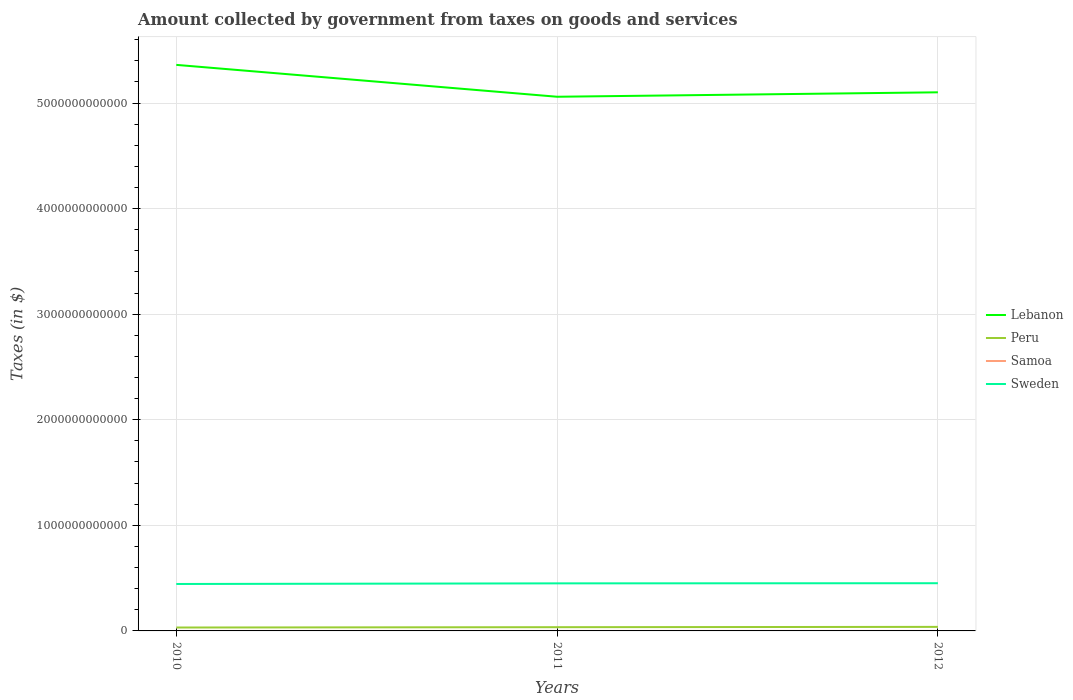Is the number of lines equal to the number of legend labels?
Your answer should be very brief. Yes. Across all years, what is the maximum amount collected by government from taxes on goods and services in Sweden?
Your answer should be very brief. 4.45e+11. In which year was the amount collected by government from taxes on goods and services in Lebanon maximum?
Your answer should be compact. 2011. What is the total amount collected by government from taxes on goods and services in Lebanon in the graph?
Offer a terse response. -4.20e+1. What is the difference between the highest and the second highest amount collected by government from taxes on goods and services in Peru?
Offer a terse response. 6.12e+09. What is the difference between the highest and the lowest amount collected by government from taxes on goods and services in Sweden?
Offer a very short reply. 2. How many years are there in the graph?
Offer a very short reply. 3. What is the difference between two consecutive major ticks on the Y-axis?
Give a very brief answer. 1.00e+12. Are the values on the major ticks of Y-axis written in scientific E-notation?
Provide a succinct answer. No. Does the graph contain any zero values?
Your answer should be compact. No. Does the graph contain grids?
Your answer should be very brief. Yes. Where does the legend appear in the graph?
Offer a terse response. Center right. How many legend labels are there?
Ensure brevity in your answer.  4. How are the legend labels stacked?
Provide a succinct answer. Vertical. What is the title of the graph?
Keep it short and to the point. Amount collected by government from taxes on goods and services. Does "Low income" appear as one of the legend labels in the graph?
Give a very brief answer. No. What is the label or title of the X-axis?
Provide a short and direct response. Years. What is the label or title of the Y-axis?
Give a very brief answer. Taxes (in $). What is the Taxes (in $) in Lebanon in 2010?
Make the answer very short. 5.36e+12. What is the Taxes (in $) in Peru in 2010?
Ensure brevity in your answer.  3.23e+1. What is the Taxes (in $) in Samoa in 2010?
Ensure brevity in your answer.  2.36e+05. What is the Taxes (in $) of Sweden in 2010?
Provide a succinct answer. 4.45e+11. What is the Taxes (in $) of Lebanon in 2011?
Make the answer very short. 5.06e+12. What is the Taxes (in $) in Peru in 2011?
Keep it short and to the point. 3.54e+1. What is the Taxes (in $) in Samoa in 2011?
Your answer should be very brief. 2.38e+05. What is the Taxes (in $) of Sweden in 2011?
Make the answer very short. 4.51e+11. What is the Taxes (in $) in Lebanon in 2012?
Offer a very short reply. 5.10e+12. What is the Taxes (in $) in Peru in 2012?
Provide a short and direct response. 3.84e+1. What is the Taxes (in $) in Samoa in 2012?
Keep it short and to the point. 2.32e+05. What is the Taxes (in $) of Sweden in 2012?
Your answer should be very brief. 4.52e+11. Across all years, what is the maximum Taxes (in $) of Lebanon?
Offer a terse response. 5.36e+12. Across all years, what is the maximum Taxes (in $) of Peru?
Offer a terse response. 3.84e+1. Across all years, what is the maximum Taxes (in $) of Samoa?
Keep it short and to the point. 2.38e+05. Across all years, what is the maximum Taxes (in $) in Sweden?
Your answer should be very brief. 4.52e+11. Across all years, what is the minimum Taxes (in $) in Lebanon?
Keep it short and to the point. 5.06e+12. Across all years, what is the minimum Taxes (in $) of Peru?
Offer a very short reply. 3.23e+1. Across all years, what is the minimum Taxes (in $) of Samoa?
Provide a succinct answer. 2.32e+05. Across all years, what is the minimum Taxes (in $) of Sweden?
Your response must be concise. 4.45e+11. What is the total Taxes (in $) of Lebanon in the graph?
Offer a very short reply. 1.55e+13. What is the total Taxes (in $) of Peru in the graph?
Provide a succinct answer. 1.06e+11. What is the total Taxes (in $) in Samoa in the graph?
Ensure brevity in your answer.  7.06e+05. What is the total Taxes (in $) in Sweden in the graph?
Your answer should be very brief. 1.35e+12. What is the difference between the Taxes (in $) of Lebanon in 2010 and that in 2011?
Your answer should be very brief. 3.02e+11. What is the difference between the Taxes (in $) of Peru in 2010 and that in 2011?
Provide a short and direct response. -3.18e+09. What is the difference between the Taxes (in $) in Samoa in 2010 and that in 2011?
Make the answer very short. -1013.36. What is the difference between the Taxes (in $) of Sweden in 2010 and that in 2011?
Keep it short and to the point. -6.03e+09. What is the difference between the Taxes (in $) in Lebanon in 2010 and that in 2012?
Provide a succinct answer. 2.60e+11. What is the difference between the Taxes (in $) in Peru in 2010 and that in 2012?
Keep it short and to the point. -6.12e+09. What is the difference between the Taxes (in $) in Samoa in 2010 and that in 2012?
Provide a succinct answer. 4110.08. What is the difference between the Taxes (in $) in Sweden in 2010 and that in 2012?
Offer a very short reply. -7.29e+09. What is the difference between the Taxes (in $) in Lebanon in 2011 and that in 2012?
Ensure brevity in your answer.  -4.20e+1. What is the difference between the Taxes (in $) in Peru in 2011 and that in 2012?
Make the answer very short. -2.94e+09. What is the difference between the Taxes (in $) in Samoa in 2011 and that in 2012?
Provide a succinct answer. 5123.44. What is the difference between the Taxes (in $) of Sweden in 2011 and that in 2012?
Your response must be concise. -1.26e+09. What is the difference between the Taxes (in $) of Lebanon in 2010 and the Taxes (in $) of Peru in 2011?
Provide a succinct answer. 5.33e+12. What is the difference between the Taxes (in $) in Lebanon in 2010 and the Taxes (in $) in Samoa in 2011?
Provide a succinct answer. 5.36e+12. What is the difference between the Taxes (in $) of Lebanon in 2010 and the Taxes (in $) of Sweden in 2011?
Offer a very short reply. 4.91e+12. What is the difference between the Taxes (in $) of Peru in 2010 and the Taxes (in $) of Samoa in 2011?
Keep it short and to the point. 3.23e+1. What is the difference between the Taxes (in $) of Peru in 2010 and the Taxes (in $) of Sweden in 2011?
Provide a succinct answer. -4.18e+11. What is the difference between the Taxes (in $) of Samoa in 2010 and the Taxes (in $) of Sweden in 2011?
Ensure brevity in your answer.  -4.51e+11. What is the difference between the Taxes (in $) of Lebanon in 2010 and the Taxes (in $) of Peru in 2012?
Make the answer very short. 5.32e+12. What is the difference between the Taxes (in $) of Lebanon in 2010 and the Taxes (in $) of Samoa in 2012?
Offer a very short reply. 5.36e+12. What is the difference between the Taxes (in $) in Lebanon in 2010 and the Taxes (in $) in Sweden in 2012?
Provide a short and direct response. 4.91e+12. What is the difference between the Taxes (in $) of Peru in 2010 and the Taxes (in $) of Samoa in 2012?
Offer a very short reply. 3.23e+1. What is the difference between the Taxes (in $) of Peru in 2010 and the Taxes (in $) of Sweden in 2012?
Offer a very short reply. -4.20e+11. What is the difference between the Taxes (in $) in Samoa in 2010 and the Taxes (in $) in Sweden in 2012?
Offer a very short reply. -4.52e+11. What is the difference between the Taxes (in $) of Lebanon in 2011 and the Taxes (in $) of Peru in 2012?
Give a very brief answer. 5.02e+12. What is the difference between the Taxes (in $) in Lebanon in 2011 and the Taxes (in $) in Samoa in 2012?
Keep it short and to the point. 5.06e+12. What is the difference between the Taxes (in $) of Lebanon in 2011 and the Taxes (in $) of Sweden in 2012?
Ensure brevity in your answer.  4.61e+12. What is the difference between the Taxes (in $) of Peru in 2011 and the Taxes (in $) of Samoa in 2012?
Offer a terse response. 3.54e+1. What is the difference between the Taxes (in $) in Peru in 2011 and the Taxes (in $) in Sweden in 2012?
Your answer should be compact. -4.16e+11. What is the difference between the Taxes (in $) in Samoa in 2011 and the Taxes (in $) in Sweden in 2012?
Your answer should be compact. -4.52e+11. What is the average Taxes (in $) of Lebanon per year?
Ensure brevity in your answer.  5.17e+12. What is the average Taxes (in $) of Peru per year?
Keep it short and to the point. 3.54e+1. What is the average Taxes (in $) of Samoa per year?
Provide a succinct answer. 2.35e+05. What is the average Taxes (in $) of Sweden per year?
Offer a very short reply. 4.49e+11. In the year 2010, what is the difference between the Taxes (in $) in Lebanon and Taxes (in $) in Peru?
Your response must be concise. 5.33e+12. In the year 2010, what is the difference between the Taxes (in $) in Lebanon and Taxes (in $) in Samoa?
Your response must be concise. 5.36e+12. In the year 2010, what is the difference between the Taxes (in $) of Lebanon and Taxes (in $) of Sweden?
Your answer should be very brief. 4.92e+12. In the year 2010, what is the difference between the Taxes (in $) in Peru and Taxes (in $) in Samoa?
Ensure brevity in your answer.  3.23e+1. In the year 2010, what is the difference between the Taxes (in $) in Peru and Taxes (in $) in Sweden?
Offer a terse response. -4.12e+11. In the year 2010, what is the difference between the Taxes (in $) in Samoa and Taxes (in $) in Sweden?
Provide a short and direct response. -4.45e+11. In the year 2011, what is the difference between the Taxes (in $) of Lebanon and Taxes (in $) of Peru?
Give a very brief answer. 5.02e+12. In the year 2011, what is the difference between the Taxes (in $) of Lebanon and Taxes (in $) of Samoa?
Make the answer very short. 5.06e+12. In the year 2011, what is the difference between the Taxes (in $) of Lebanon and Taxes (in $) of Sweden?
Give a very brief answer. 4.61e+12. In the year 2011, what is the difference between the Taxes (in $) in Peru and Taxes (in $) in Samoa?
Provide a succinct answer. 3.54e+1. In the year 2011, what is the difference between the Taxes (in $) of Peru and Taxes (in $) of Sweden?
Provide a short and direct response. -4.15e+11. In the year 2011, what is the difference between the Taxes (in $) of Samoa and Taxes (in $) of Sweden?
Give a very brief answer. -4.51e+11. In the year 2012, what is the difference between the Taxes (in $) in Lebanon and Taxes (in $) in Peru?
Provide a succinct answer. 5.06e+12. In the year 2012, what is the difference between the Taxes (in $) of Lebanon and Taxes (in $) of Samoa?
Your response must be concise. 5.10e+12. In the year 2012, what is the difference between the Taxes (in $) in Lebanon and Taxes (in $) in Sweden?
Provide a succinct answer. 4.65e+12. In the year 2012, what is the difference between the Taxes (in $) in Peru and Taxes (in $) in Samoa?
Ensure brevity in your answer.  3.84e+1. In the year 2012, what is the difference between the Taxes (in $) in Peru and Taxes (in $) in Sweden?
Provide a short and direct response. -4.13e+11. In the year 2012, what is the difference between the Taxes (in $) in Samoa and Taxes (in $) in Sweden?
Give a very brief answer. -4.52e+11. What is the ratio of the Taxes (in $) in Lebanon in 2010 to that in 2011?
Offer a terse response. 1.06. What is the ratio of the Taxes (in $) in Peru in 2010 to that in 2011?
Your answer should be compact. 0.91. What is the ratio of the Taxes (in $) in Samoa in 2010 to that in 2011?
Your response must be concise. 1. What is the ratio of the Taxes (in $) in Sweden in 2010 to that in 2011?
Keep it short and to the point. 0.99. What is the ratio of the Taxes (in $) in Lebanon in 2010 to that in 2012?
Keep it short and to the point. 1.05. What is the ratio of the Taxes (in $) of Peru in 2010 to that in 2012?
Provide a short and direct response. 0.84. What is the ratio of the Taxes (in $) in Samoa in 2010 to that in 2012?
Keep it short and to the point. 1.02. What is the ratio of the Taxes (in $) of Sweden in 2010 to that in 2012?
Your answer should be compact. 0.98. What is the ratio of the Taxes (in $) in Peru in 2011 to that in 2012?
Your answer should be compact. 0.92. What is the difference between the highest and the second highest Taxes (in $) of Lebanon?
Offer a very short reply. 2.60e+11. What is the difference between the highest and the second highest Taxes (in $) of Peru?
Provide a short and direct response. 2.94e+09. What is the difference between the highest and the second highest Taxes (in $) of Samoa?
Keep it short and to the point. 1013.36. What is the difference between the highest and the second highest Taxes (in $) in Sweden?
Ensure brevity in your answer.  1.26e+09. What is the difference between the highest and the lowest Taxes (in $) in Lebanon?
Provide a short and direct response. 3.02e+11. What is the difference between the highest and the lowest Taxes (in $) in Peru?
Provide a short and direct response. 6.12e+09. What is the difference between the highest and the lowest Taxes (in $) in Samoa?
Your answer should be compact. 5123.44. What is the difference between the highest and the lowest Taxes (in $) of Sweden?
Your answer should be very brief. 7.29e+09. 